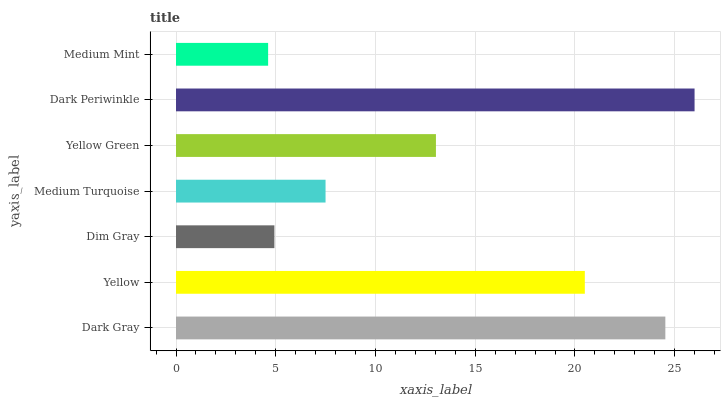Is Medium Mint the minimum?
Answer yes or no. Yes. Is Dark Periwinkle the maximum?
Answer yes or no. Yes. Is Yellow the minimum?
Answer yes or no. No. Is Yellow the maximum?
Answer yes or no. No. Is Dark Gray greater than Yellow?
Answer yes or no. Yes. Is Yellow less than Dark Gray?
Answer yes or no. Yes. Is Yellow greater than Dark Gray?
Answer yes or no. No. Is Dark Gray less than Yellow?
Answer yes or no. No. Is Yellow Green the high median?
Answer yes or no. Yes. Is Yellow Green the low median?
Answer yes or no. Yes. Is Dark Gray the high median?
Answer yes or no. No. Is Yellow the low median?
Answer yes or no. No. 